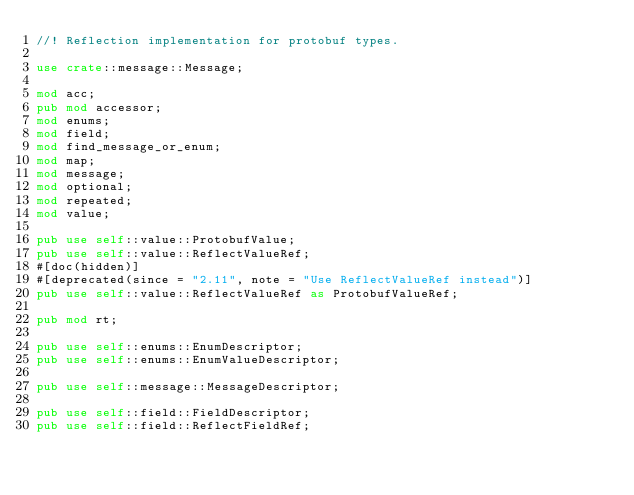Convert code to text. <code><loc_0><loc_0><loc_500><loc_500><_Rust_>//! Reflection implementation for protobuf types.

use crate::message::Message;

mod acc;
pub mod accessor;
mod enums;
mod field;
mod find_message_or_enum;
mod map;
mod message;
mod optional;
mod repeated;
mod value;

pub use self::value::ProtobufValue;
pub use self::value::ReflectValueRef;
#[doc(hidden)]
#[deprecated(since = "2.11", note = "Use ReflectValueRef instead")]
pub use self::value::ReflectValueRef as ProtobufValueRef;

pub mod rt;

pub use self::enums::EnumDescriptor;
pub use self::enums::EnumValueDescriptor;

pub use self::message::MessageDescriptor;

pub use self::field::FieldDescriptor;
pub use self::field::ReflectFieldRef;
</code> 